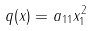<formula> <loc_0><loc_0><loc_500><loc_500>q ( x ) = a _ { 1 1 } x _ { 1 } ^ { 2 }</formula> 